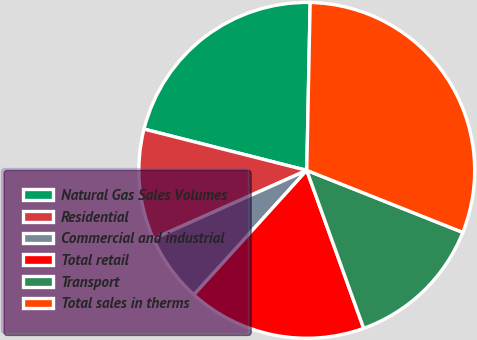Convert chart to OTSL. <chart><loc_0><loc_0><loc_500><loc_500><pie_chart><fcel>Natural Gas Sales Volumes<fcel>Residential<fcel>Commercial and industrial<fcel>Total retail<fcel>Transport<fcel>Total sales in therms<nl><fcel>21.37%<fcel>10.64%<fcel>6.59%<fcel>17.23%<fcel>13.47%<fcel>30.7%<nl></chart> 